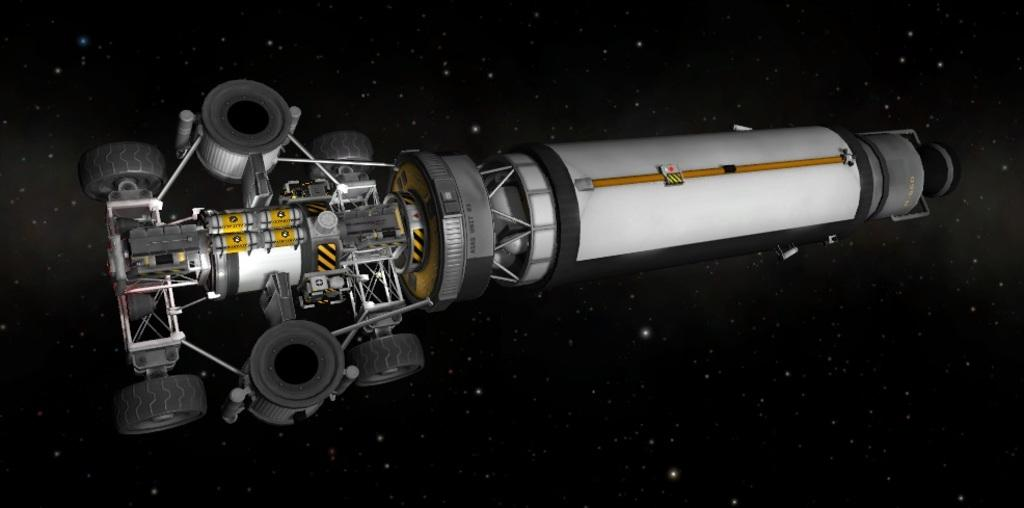What is the main subject of the image? The main subject of the image is an engine in the air. What can be observed about the background of the image? The background of the image is dark. How many seats are visible in the image? There are no seats present in the image. What type of detail can be seen on the engine in the image? The image does not provide enough detail to identify any specific details on the engine. 